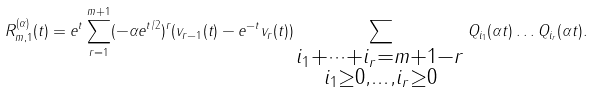Convert formula to latex. <formula><loc_0><loc_0><loc_500><loc_500>R _ { m , 1 } ^ { ( \alpha ) } ( t ) = e ^ { t } \sum _ { r = 1 } ^ { m + 1 } ( - \alpha e ^ { t / 2 } ) ^ { r } ( v _ { r - 1 } ( t ) - e ^ { - t } v _ { r } ( t ) ) \sum _ { \substack { i _ { 1 } + \dots + i _ { r } = m + 1 - r \\ i _ { 1 } \geq 0 , \dots , i _ { r } \geq 0 } } Q _ { i _ { 1 } } ( \alpha t ) \dots Q _ { i _ { r } } ( \alpha t ) .</formula> 